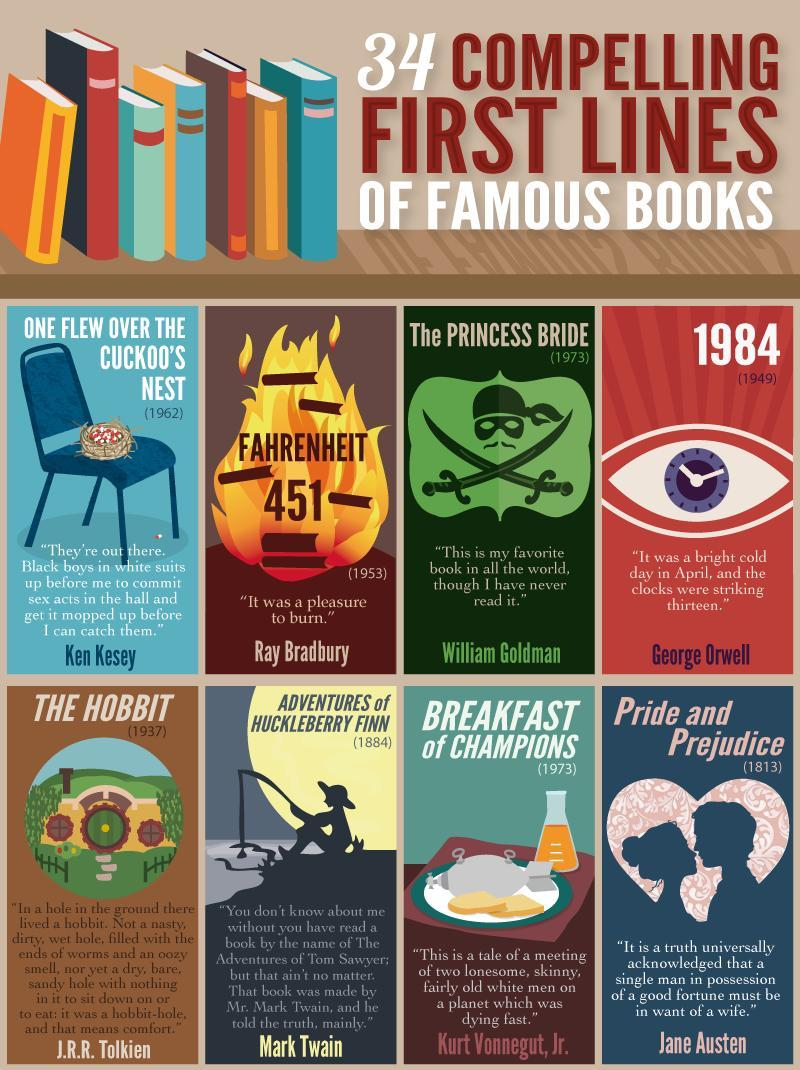When was the book titled 'Breakfast of Champions' published?
Answer the question with a short phrase. 1973 Who is the author of 'THE HOBBIT'? J.R.R. Tolkien What is the first line of 'FAHRENHEIT 451'? “It was a pleasure to burn.” Who is the author of 'Pride and Prejudice'? Jane Austen Which book was published in 1949 among the most famous books? 1984 When was the book titled 'The PRINCESS BRIDE' published? 1973 